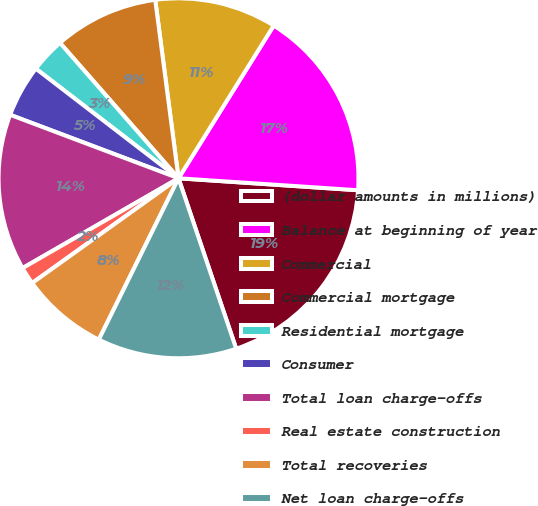Convert chart to OTSL. <chart><loc_0><loc_0><loc_500><loc_500><pie_chart><fcel>(dollar amounts in millions)<fcel>Balance at beginning of year<fcel>Commercial<fcel>Commercial mortgage<fcel>Residential mortgage<fcel>Consumer<fcel>Total loan charge-offs<fcel>Real estate construction<fcel>Total recoveries<fcel>Net loan charge-offs<nl><fcel>18.75%<fcel>17.19%<fcel>10.94%<fcel>9.38%<fcel>3.13%<fcel>4.69%<fcel>14.06%<fcel>1.57%<fcel>7.81%<fcel>12.5%<nl></chart> 